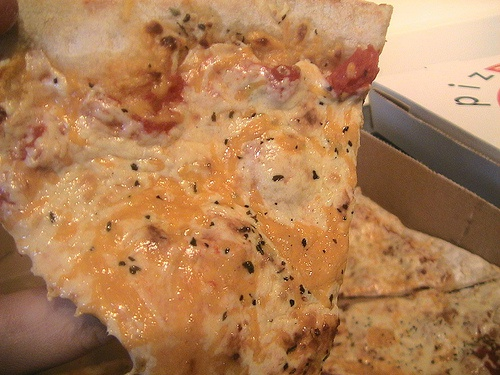Describe the objects in this image and their specific colors. I can see a pizza in maroon, tan, brown, and salmon tones in this image. 